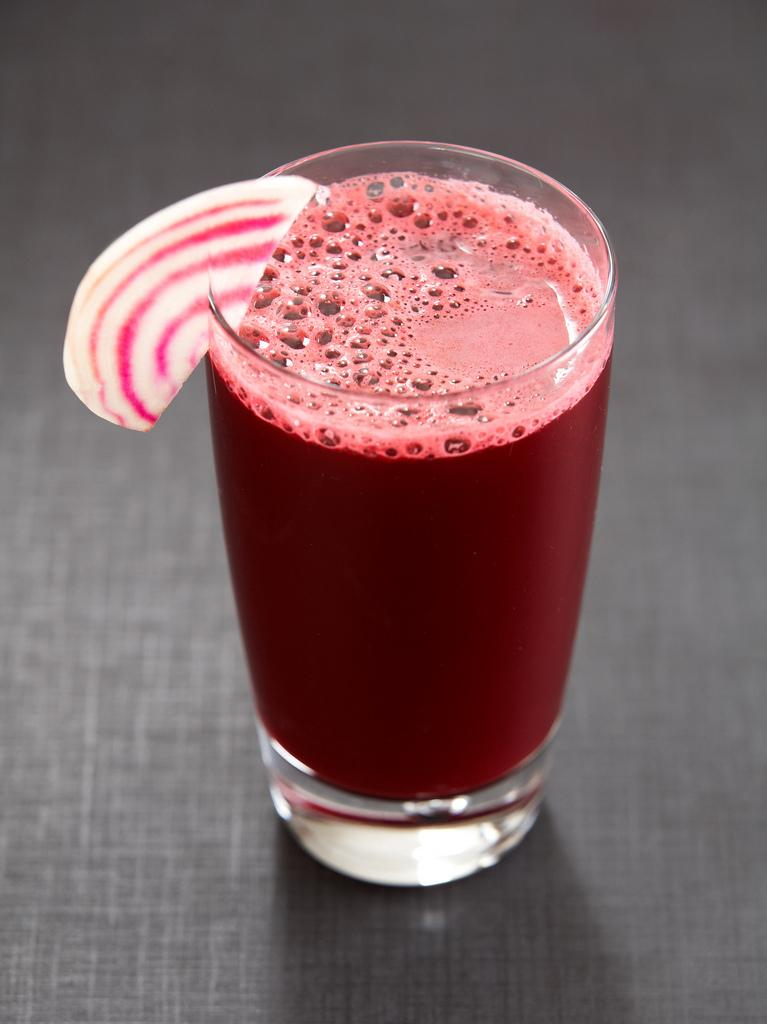What is in the glass that is visible in the image? There is juice in a glass in the image. What is the color of the surface on which the glass is placed? The surface is black in color. What type of fog can be seen in the image? There is no fog present in the image. What time does the clock show in the image? There is no clock present in the image. 